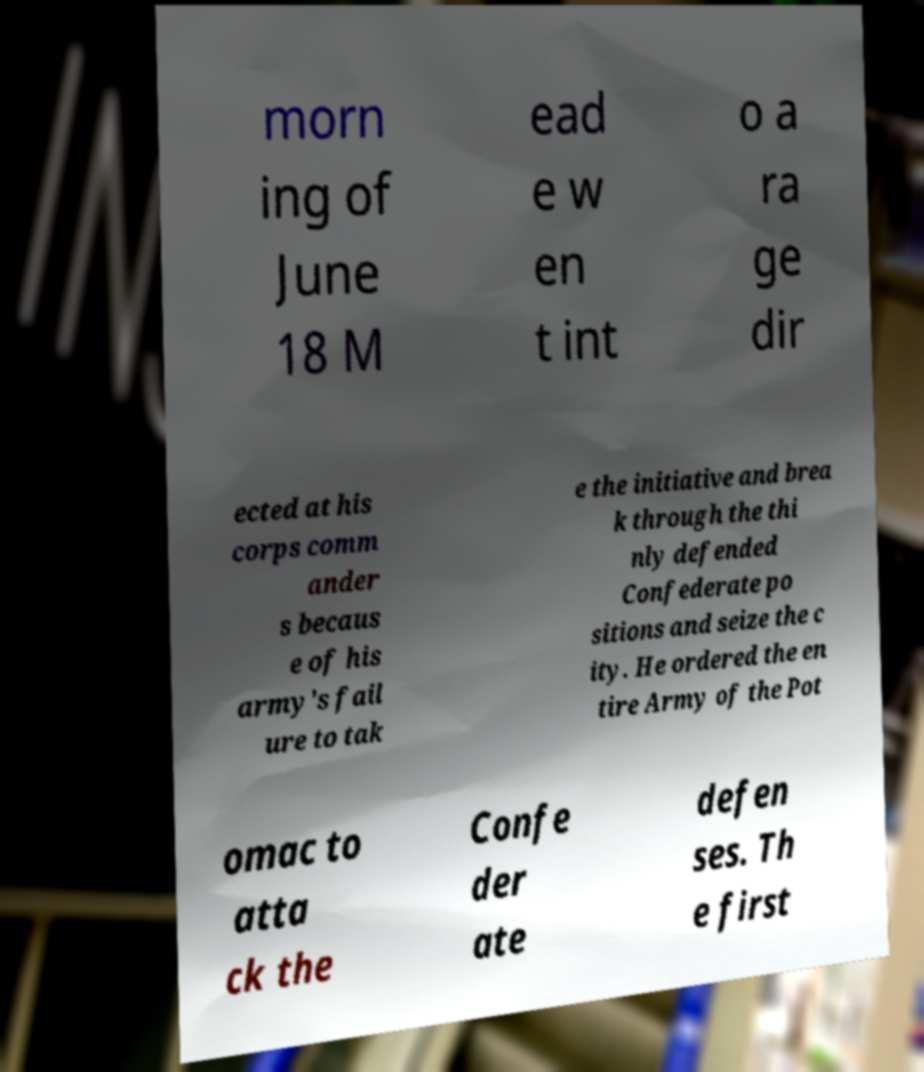For documentation purposes, I need the text within this image transcribed. Could you provide that? morn ing of June 18 M ead e w en t int o a ra ge dir ected at his corps comm ander s becaus e of his army's fail ure to tak e the initiative and brea k through the thi nly defended Confederate po sitions and seize the c ity. He ordered the en tire Army of the Pot omac to atta ck the Confe der ate defen ses. Th e first 